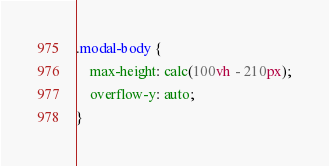Convert code to text. <code><loc_0><loc_0><loc_500><loc_500><_CSS_>.modal-body {
    max-height: calc(100vh - 210px);
    overflow-y: auto;
}</code> 